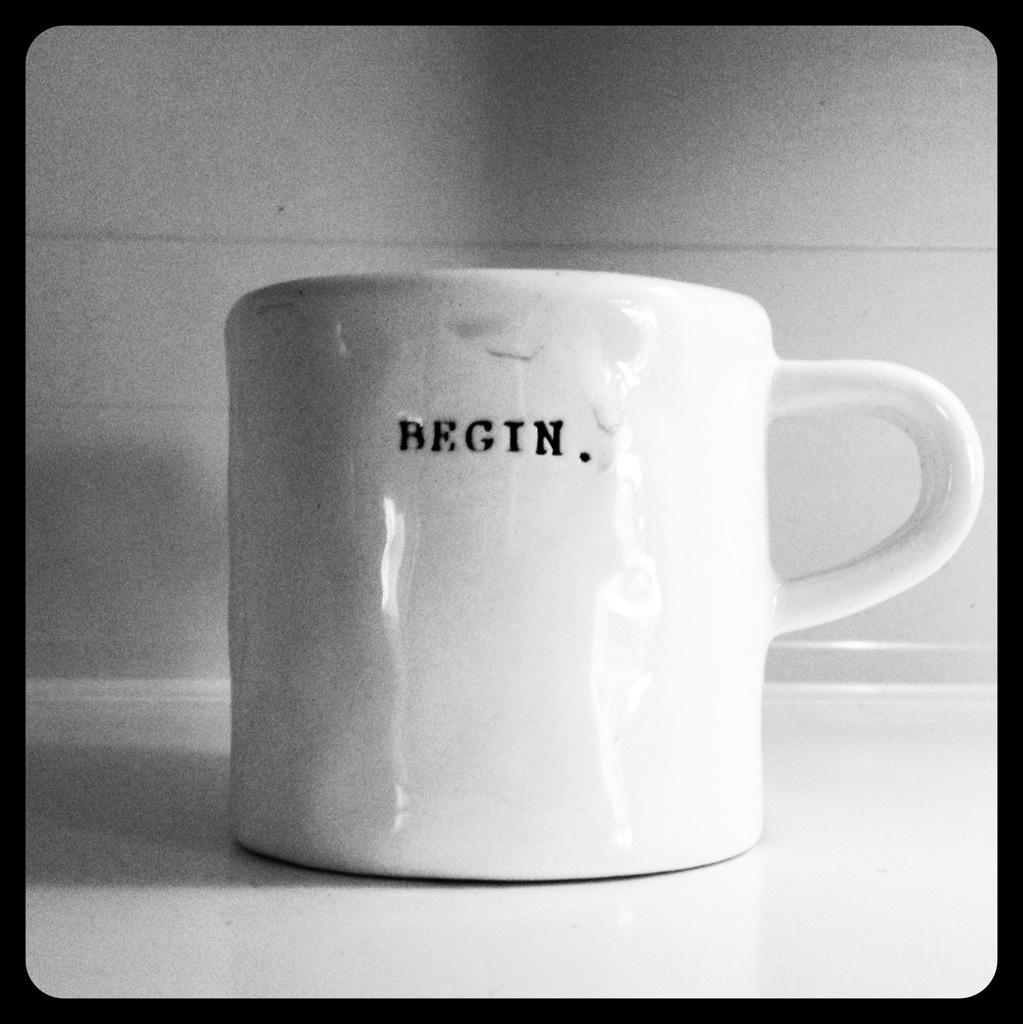<image>
Create a compact narrative representing the image presented. A white mug with "Begin" written on it in small text. 